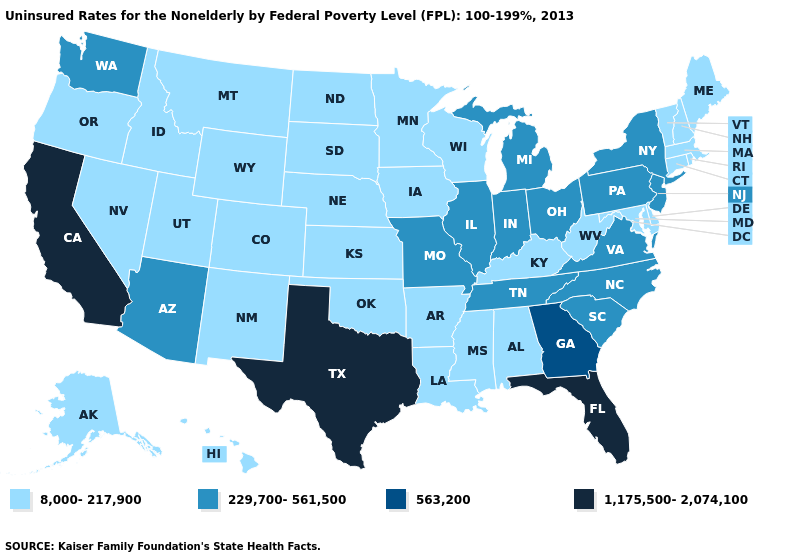What is the lowest value in states that border Indiana?
Short answer required. 8,000-217,900. What is the value of California?
Give a very brief answer. 1,175,500-2,074,100. Name the states that have a value in the range 229,700-561,500?
Keep it brief. Arizona, Illinois, Indiana, Michigan, Missouri, New Jersey, New York, North Carolina, Ohio, Pennsylvania, South Carolina, Tennessee, Virginia, Washington. What is the value of North Dakota?
Keep it brief. 8,000-217,900. Does Alaska have the lowest value in the West?
Quick response, please. Yes. Name the states that have a value in the range 8,000-217,900?
Keep it brief. Alabama, Alaska, Arkansas, Colorado, Connecticut, Delaware, Hawaii, Idaho, Iowa, Kansas, Kentucky, Louisiana, Maine, Maryland, Massachusetts, Minnesota, Mississippi, Montana, Nebraska, Nevada, New Hampshire, New Mexico, North Dakota, Oklahoma, Oregon, Rhode Island, South Dakota, Utah, Vermont, West Virginia, Wisconsin, Wyoming. What is the highest value in the USA?
Short answer required. 1,175,500-2,074,100. What is the lowest value in the MidWest?
Give a very brief answer. 8,000-217,900. Does Florida have the lowest value in the South?
Quick response, please. No. What is the lowest value in the Northeast?
Give a very brief answer. 8,000-217,900. What is the highest value in states that border Montana?
Answer briefly. 8,000-217,900. How many symbols are there in the legend?
Keep it brief. 4. How many symbols are there in the legend?
Answer briefly. 4. How many symbols are there in the legend?
Quick response, please. 4. Which states have the lowest value in the West?
Keep it brief. Alaska, Colorado, Hawaii, Idaho, Montana, Nevada, New Mexico, Oregon, Utah, Wyoming. 